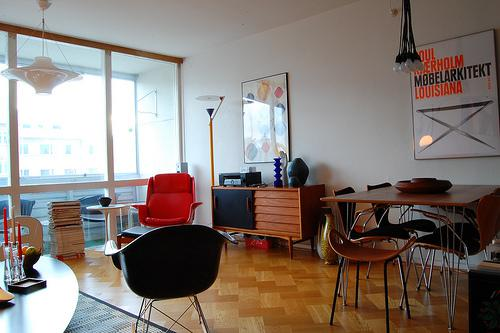Question: where is the red chair?
Choices:
A. Under the table.
B. Behind the door.
C. Near the window.
D. Across the sofa.
Answer with the letter. Answer: C Question: where are the vases?
Choices:
A. Counter.
B. Table.
C. On the cabinet.
D. Balcony.
Answer with the letter. Answer: C Question: how many chairs are in the room?
Choices:
A. Eight.
B. Nine.
C. Seven.
D. Ten.
Answer with the letter. Answer: C Question: where is the brown bowl?
Choices:
A. On the dining table.
B. Counter.
C. Floor.
D. Ground.
Answer with the letter. Answer: A 